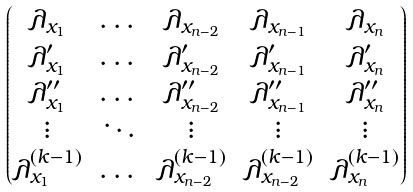<formula> <loc_0><loc_0><loc_500><loc_500>\begin{pmatrix} \lambda _ { x _ { 1 } } & \dots & \lambda _ { x _ { n - 2 } } & \lambda _ { x _ { n - 1 } } & \lambda _ { x _ { n } } \\ \lambda ^ { \prime } _ { x _ { 1 } } & \dots & \lambda ^ { \prime } _ { x _ { n - 2 } } & \lambda ^ { \prime } _ { x _ { n - 1 } } & \lambda ^ { \prime } _ { x _ { n } } \\ \lambda ^ { \prime \prime } _ { x _ { 1 } } & \dots & \lambda ^ { \prime \prime } _ { x _ { n - 2 } } & \lambda ^ { \prime \prime } _ { x _ { n - 1 } } & \lambda ^ { \prime \prime } _ { x _ { n } } \\ \vdots & \ddots & \vdots & \vdots & \vdots \\ \lambda ^ { ( k - 1 ) } _ { x _ { 1 } } & \dots & \lambda ^ { ( k - 1 ) } _ { x _ { n - 2 } } & \lambda ^ { ( k - 1 ) } _ { x _ { n - 2 } } & \lambda ^ { ( k - 1 ) } _ { x _ { n } } \end{pmatrix}</formula> 